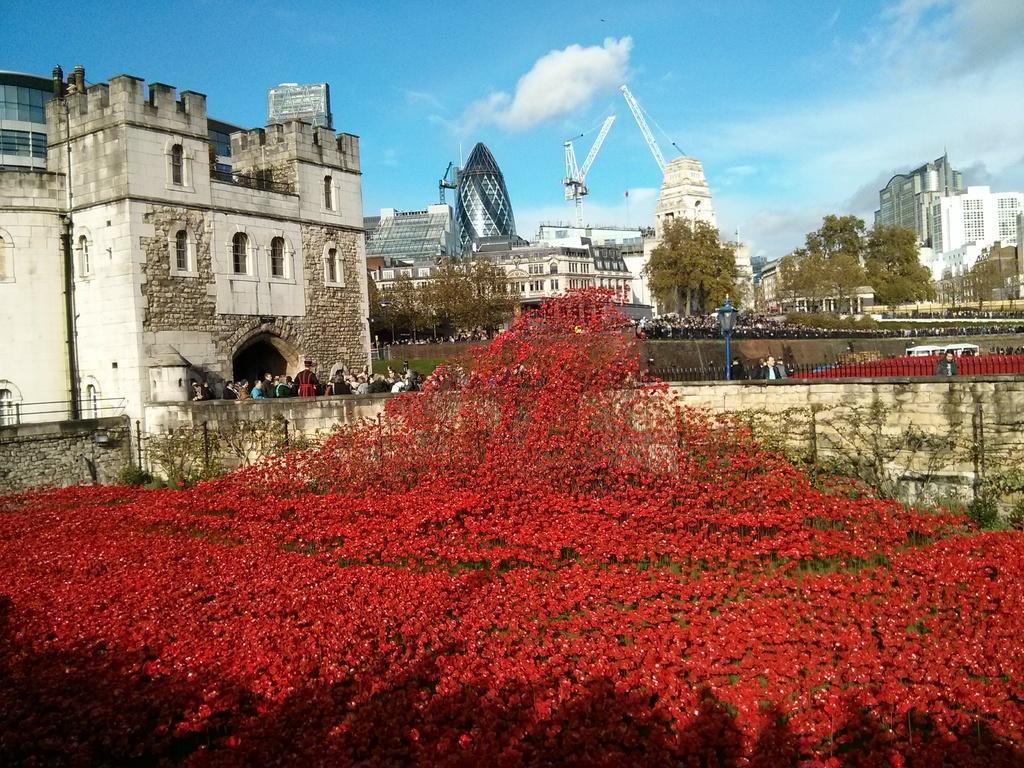Please provide a concise description of this image. In this picture there are red color flowers and buildings and in front of the building persons, poles ,trees and there are some buildings visible in the middle at the top I can see the sky. 